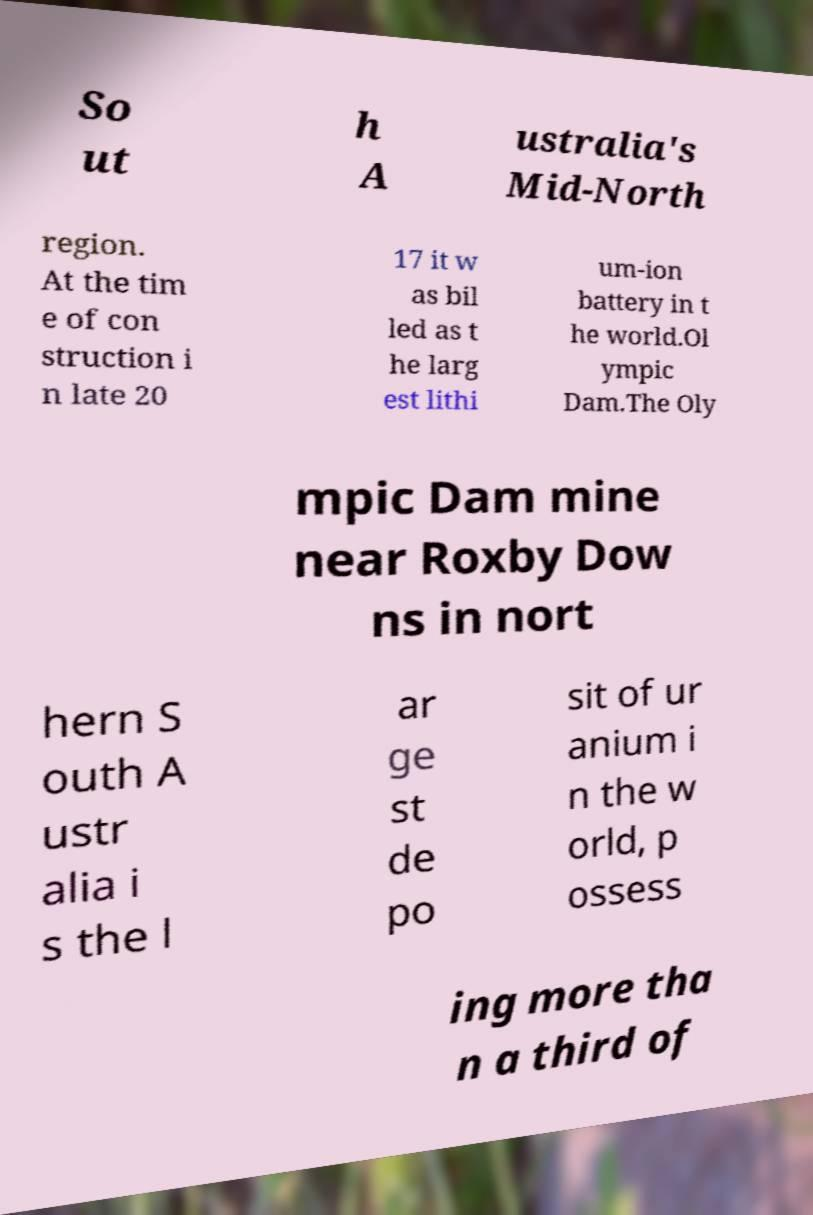Please identify and transcribe the text found in this image. So ut h A ustralia's Mid-North region. At the tim e of con struction i n late 20 17 it w as bil led as t he larg est lithi um-ion battery in t he world.Ol ympic Dam.The Oly mpic Dam mine near Roxby Dow ns in nort hern S outh A ustr alia i s the l ar ge st de po sit of ur anium i n the w orld, p ossess ing more tha n a third of 